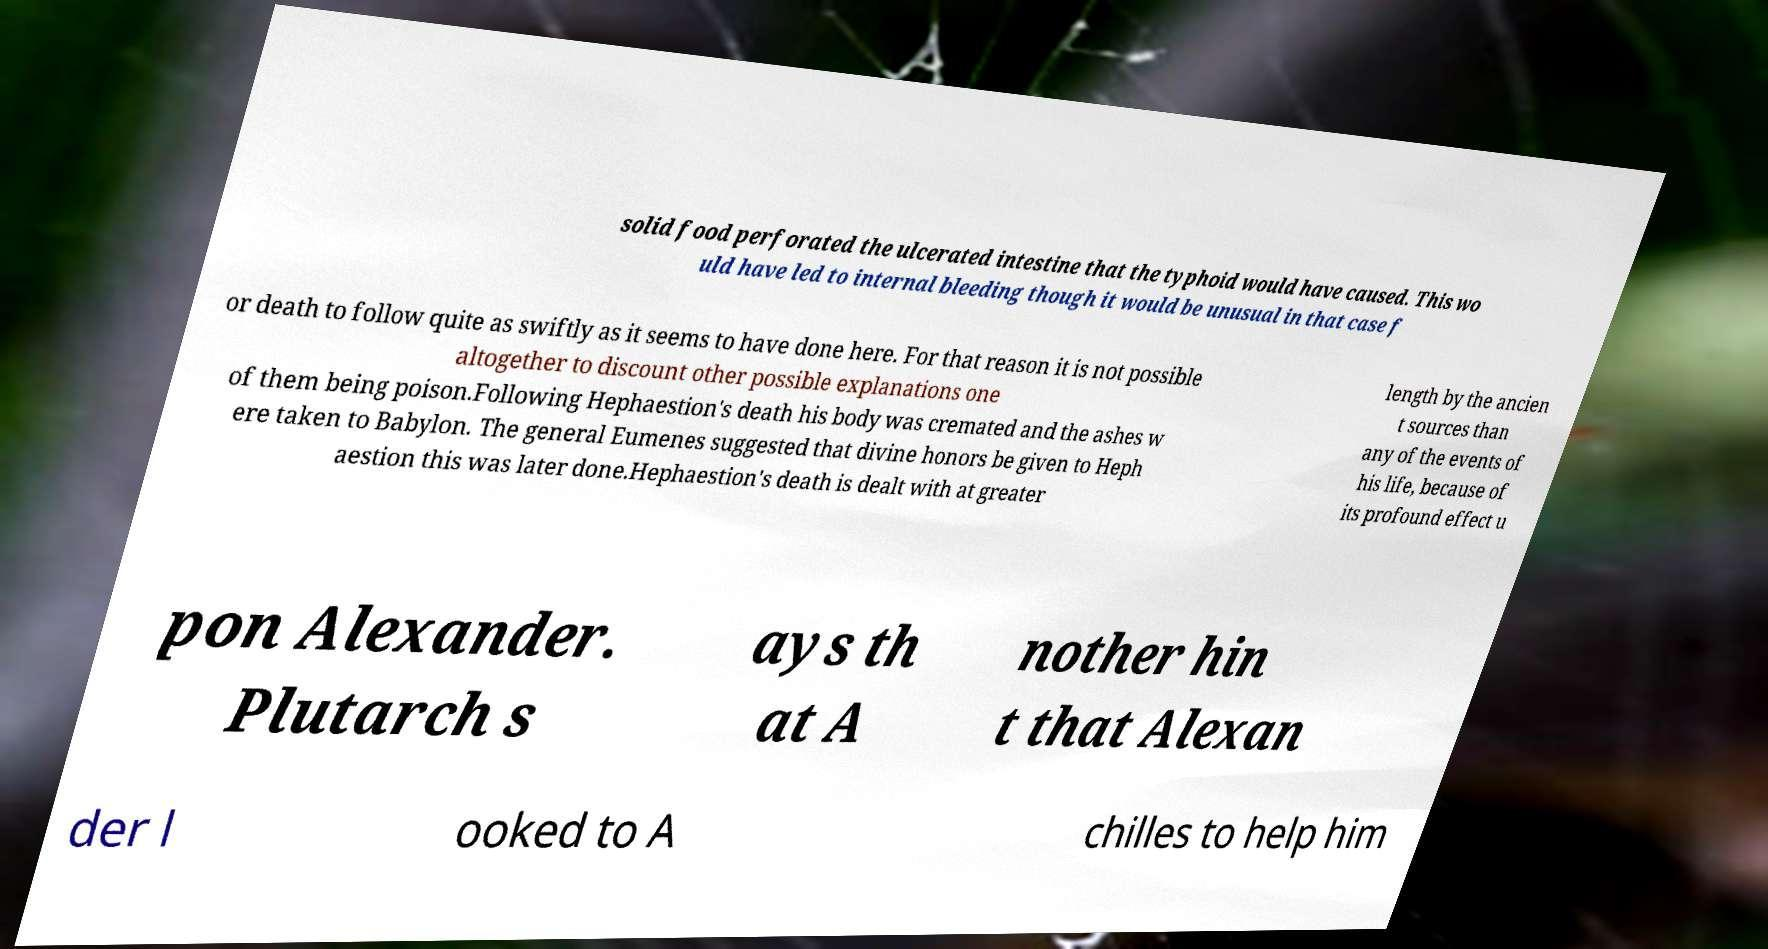What messages or text are displayed in this image? I need them in a readable, typed format. solid food perforated the ulcerated intestine that the typhoid would have caused. This wo uld have led to internal bleeding though it would be unusual in that case f or death to follow quite as swiftly as it seems to have done here. For that reason it is not possible altogether to discount other possible explanations one of them being poison.Following Hephaestion's death his body was cremated and the ashes w ere taken to Babylon. The general Eumenes suggested that divine honors be given to Heph aestion this was later done.Hephaestion's death is dealt with at greater length by the ancien t sources than any of the events of his life, because of its profound effect u pon Alexander. Plutarch s ays th at A nother hin t that Alexan der l ooked to A chilles to help him 